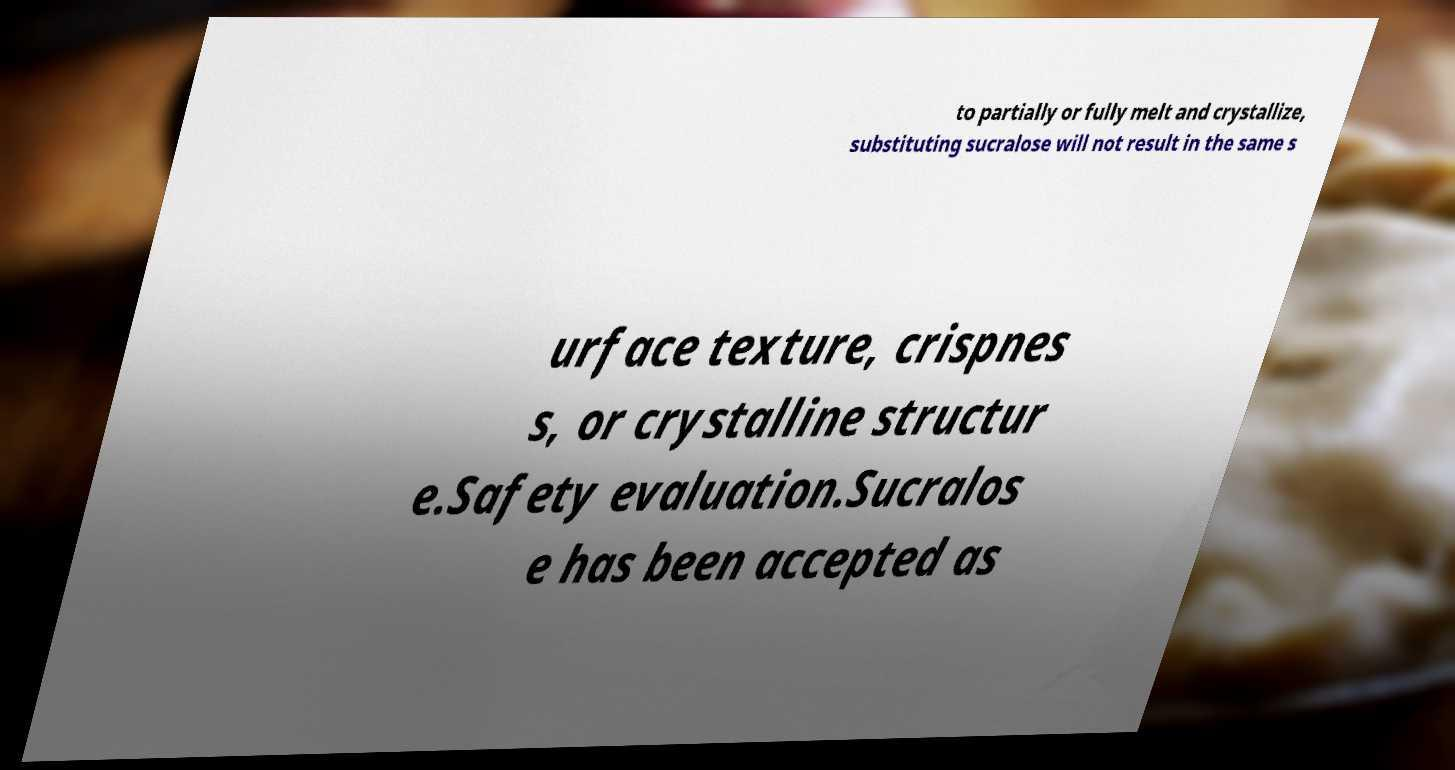Can you accurately transcribe the text from the provided image for me? to partially or fully melt and crystallize, substituting sucralose will not result in the same s urface texture, crispnes s, or crystalline structur e.Safety evaluation.Sucralos e has been accepted as 